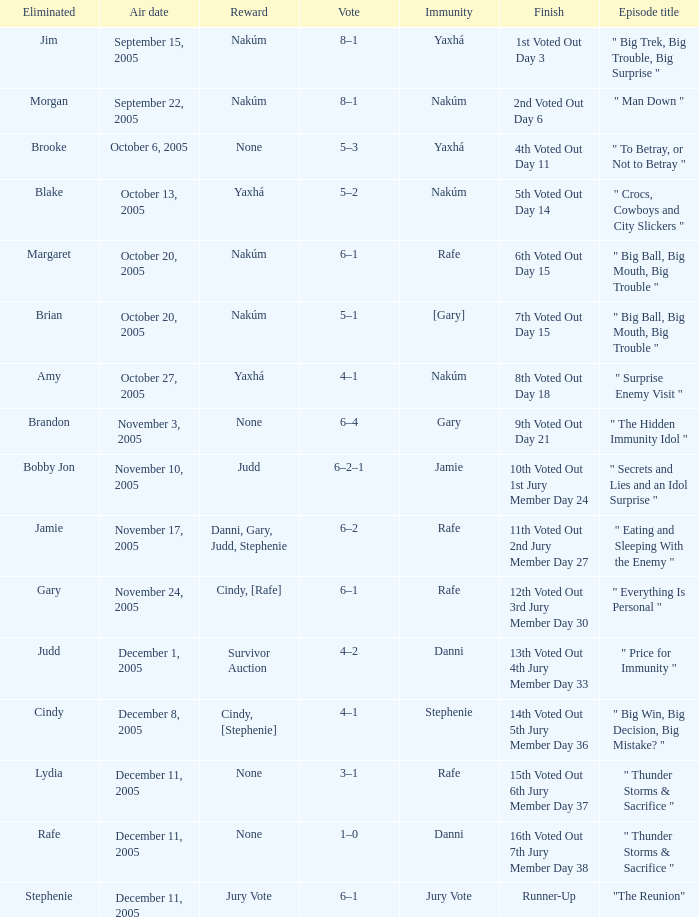When jim is eliminated what is the finish? 1st Voted Out Day 3. 